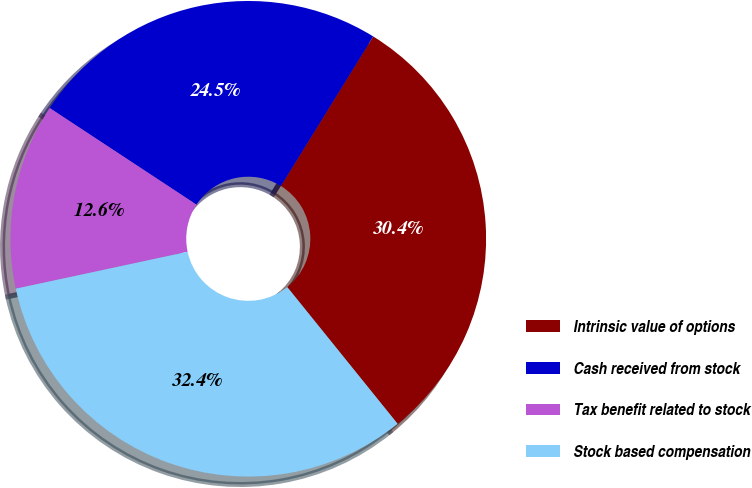<chart> <loc_0><loc_0><loc_500><loc_500><pie_chart><fcel>Intrinsic value of options<fcel>Cash received from stock<fcel>Tax benefit related to stock<fcel>Stock based compensation<nl><fcel>30.39%<fcel>24.54%<fcel>12.63%<fcel>32.44%<nl></chart> 